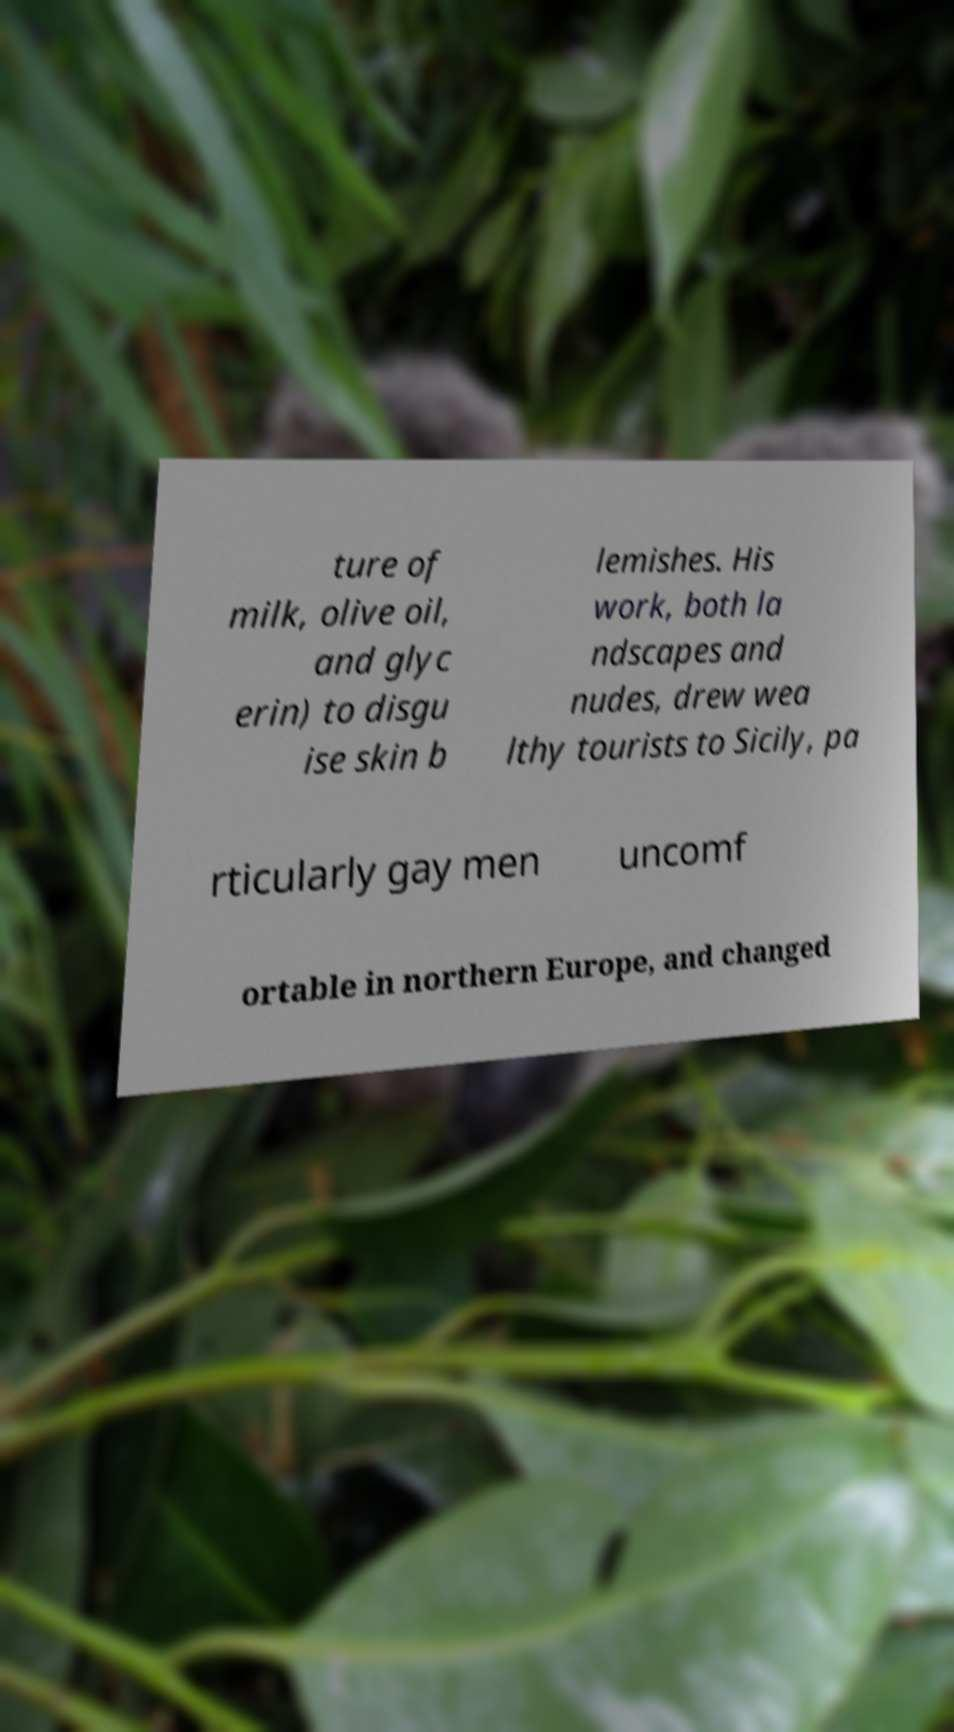Can you accurately transcribe the text from the provided image for me? ture of milk, olive oil, and glyc erin) to disgu ise skin b lemishes. His work, both la ndscapes and nudes, drew wea lthy tourists to Sicily, pa rticularly gay men uncomf ortable in northern Europe, and changed 